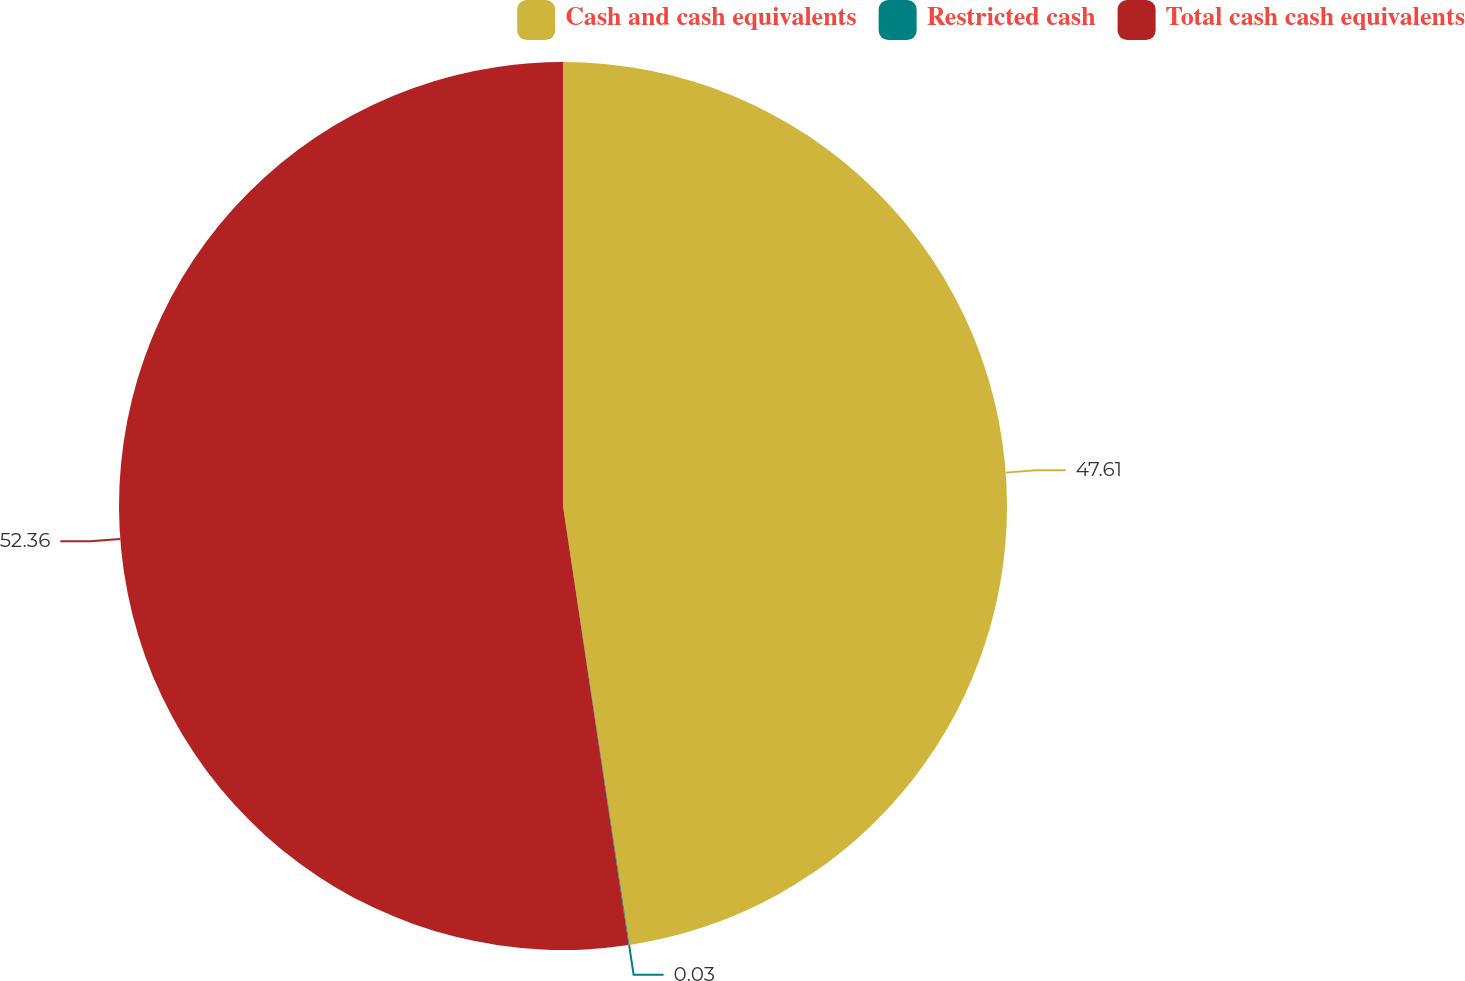Convert chart. <chart><loc_0><loc_0><loc_500><loc_500><pie_chart><fcel>Cash and cash equivalents<fcel>Restricted cash<fcel>Total cash cash equivalents<nl><fcel>47.61%<fcel>0.03%<fcel>52.37%<nl></chart> 